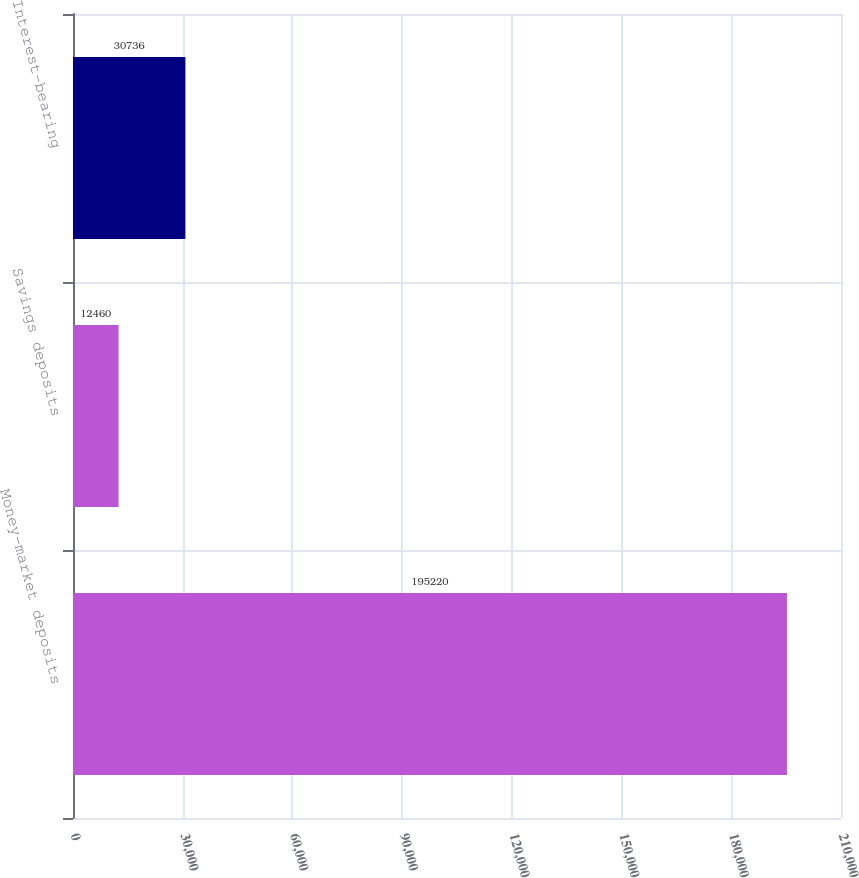<chart> <loc_0><loc_0><loc_500><loc_500><bar_chart><fcel>Money-market deposits<fcel>Savings deposits<fcel>Interest-bearing<nl><fcel>195220<fcel>12460<fcel>30736<nl></chart> 